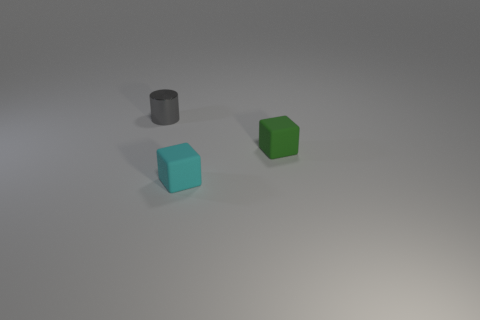There is another small matte thing that is the same shape as the tiny cyan thing; what color is it?
Give a very brief answer. Green. Are there the same number of tiny gray cylinders on the left side of the green cube and small cyan cubes?
Your answer should be compact. Yes. How many balls are small green objects or small shiny objects?
Offer a very short reply. 0. What is the color of the other block that is the same material as the small green block?
Provide a short and direct response. Cyan. Is the small green object made of the same material as the thing that is to the left of the tiny cyan rubber cube?
Your answer should be compact. No. How many objects are either blue cylinders or tiny gray shiny objects?
Keep it short and to the point. 1. Are there any other rubber things that have the same shape as the green object?
Ensure brevity in your answer.  Yes. How many tiny green matte blocks are in front of the small gray shiny cylinder?
Keep it short and to the point. 1. There is a tiny object that is on the right side of the tiny rubber thing that is in front of the green object; what is its material?
Offer a terse response. Rubber. There is a cylinder that is the same size as the green rubber object; what material is it?
Your answer should be compact. Metal. 